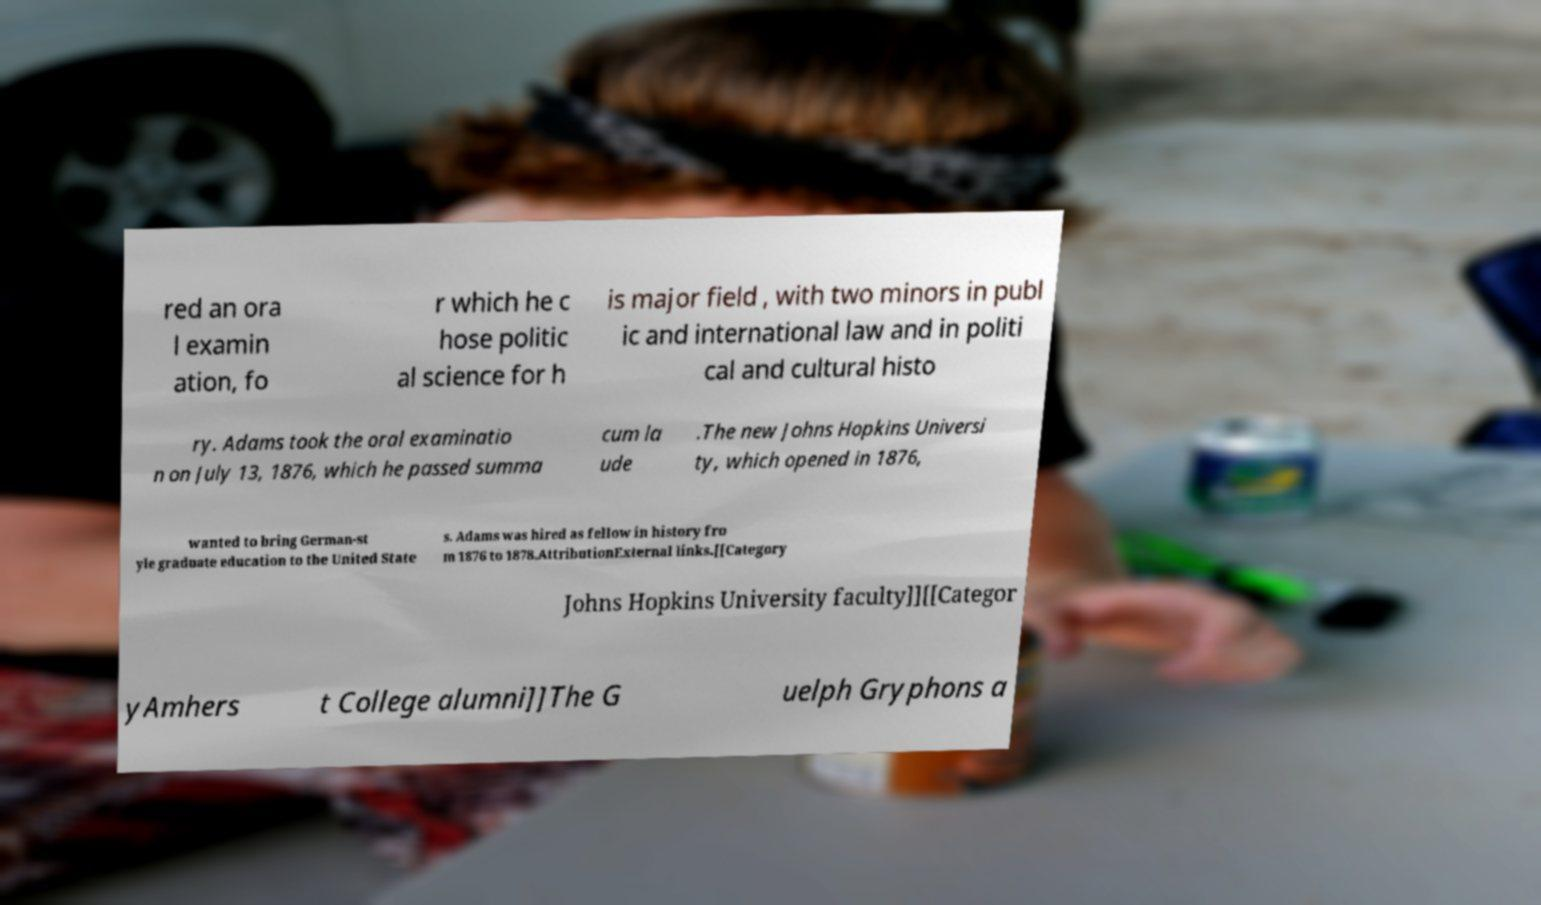Could you assist in decoding the text presented in this image and type it out clearly? red an ora l examin ation, fo r which he c hose politic al science for h is major field , with two minors in publ ic and international law and in politi cal and cultural histo ry. Adams took the oral examinatio n on July 13, 1876, which he passed summa cum la ude .The new Johns Hopkins Universi ty, which opened in 1876, wanted to bring German-st yle graduate education to the United State s. Adams was hired as fellow in history fro m 1876 to 1878,AttributionExternal links.[[Category Johns Hopkins University faculty]][[Categor yAmhers t College alumni]]The G uelph Gryphons a 